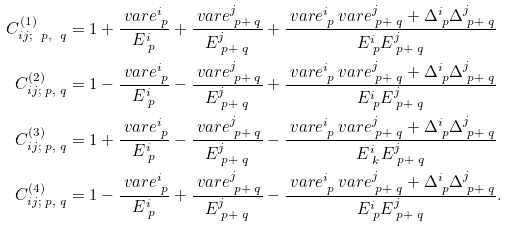Convert formula to latex. <formula><loc_0><loc_0><loc_500><loc_500>C ^ { ( 1 ) } _ { i j ; \ p , \ q } & = 1 + \frac { \ v a r e _ { \ p } ^ { i } } { E _ { \ p } ^ { i } } + \frac { \ v a r e _ { \ p + \ q } ^ { j } } { E _ { \ p + \ q } ^ { j } } + \frac { \ v a r e _ { \ p } ^ { i } \ v a r e _ { \ p + \ q } ^ { j } + \Delta _ { \ p } ^ { i } \Delta _ { \ p + \ q } ^ { j } } { E _ { \ p } ^ { i } E _ { \ p + \ q } ^ { j } } \\ C ^ { ( 2 ) } _ { i j ; \ p , \ q } & = 1 - \frac { \ v a r e _ { \ p } ^ { i } } { E _ { \ p } ^ { i } } - \frac { \ v a r e _ { \ p + \ q } ^ { j } } { E _ { \ p + \ q } ^ { j } } + \frac { \ v a r e _ { \ p } ^ { i } \ v a r e _ { \ p + \ q } ^ { j } + \Delta _ { \ p } ^ { i } \Delta _ { \ p + \ q } ^ { j } } { E _ { \ p } ^ { i } E _ { \ p + \ q } ^ { j } } \\ C ^ { ( 3 ) } _ { i j ; \ p , \ q } & = 1 + \frac { \ v a r e _ { \ p } ^ { i } } { E _ { \ p } ^ { i } } - \frac { \ v a r e _ { \ p + \ q } ^ { j } } { E _ { \ p + \ q } ^ { j } } - \frac { \ v a r e _ { \ p } ^ { i } \ v a r e _ { \ p + \ q } ^ { j } + \Delta _ { \ p } ^ { i } \Delta _ { \ p + \ q } ^ { j } } { E _ { \ k } ^ { i } E _ { \ p + \ q } ^ { j } } \\ C ^ { ( 4 ) } _ { i j ; \ p , \ q } & = 1 - \frac { \ v a r e _ { \ p } ^ { i } } { E _ { \ p } ^ { i } } + \frac { \ v a r e _ { \ p + \ q } ^ { j } } { E _ { \ p + \ q } ^ { j } } - \frac { \ v a r e _ { \ p } ^ { i } \ v a r e _ { \ p + \ q } ^ { j } + \Delta _ { \ p } ^ { i } \Delta _ { \ p + \ q } ^ { j } } { E _ { \ p } ^ { i } E _ { \ p + \ q } ^ { j } } .</formula> 